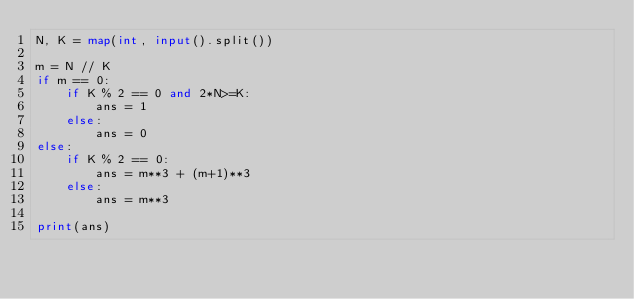<code> <loc_0><loc_0><loc_500><loc_500><_Python_>N, K = map(int, input().split())

m = N // K
if m == 0:
    if K % 2 == 0 and 2*N>=K:
        ans = 1
    else:
        ans = 0
else:
    if K % 2 == 0:
        ans = m**3 + (m+1)**3
    else:
        ans = m**3

print(ans)</code> 